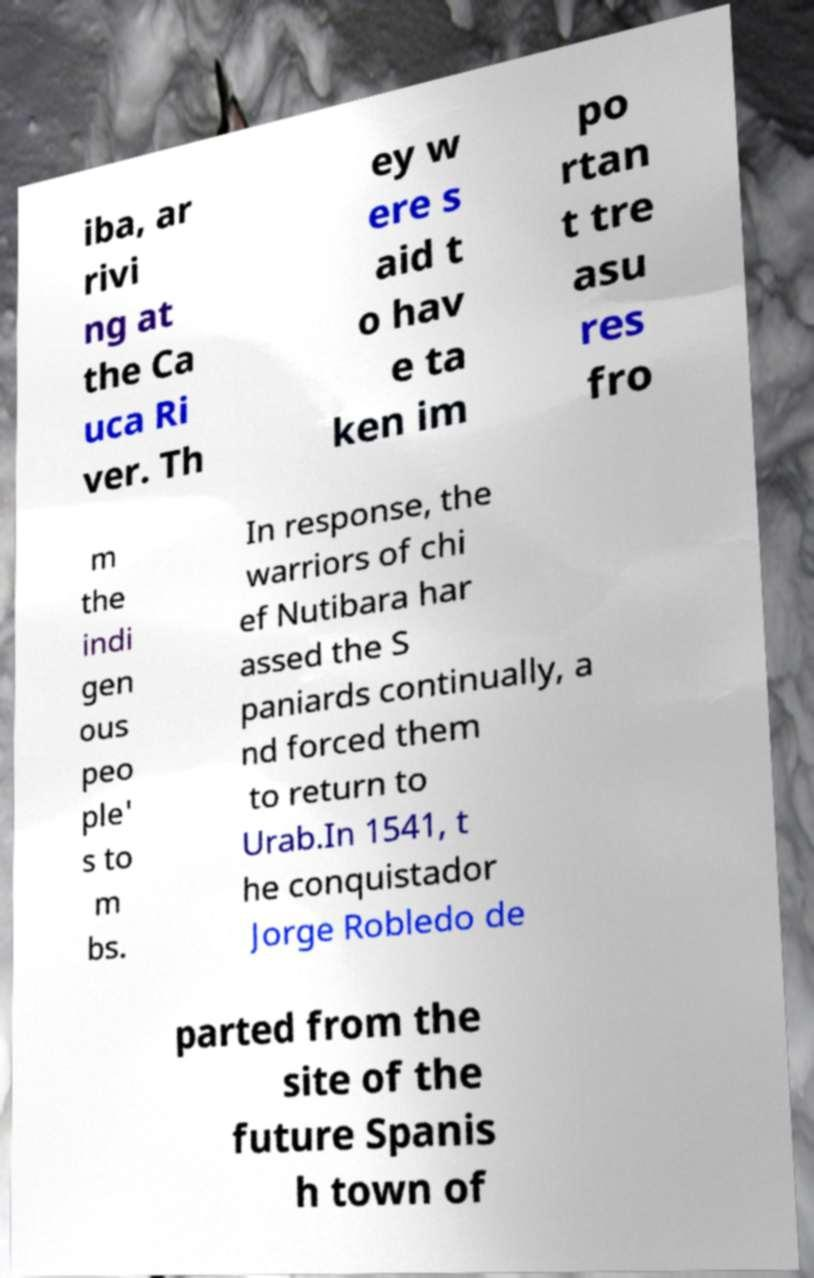Please identify and transcribe the text found in this image. iba, ar rivi ng at the Ca uca Ri ver. Th ey w ere s aid t o hav e ta ken im po rtan t tre asu res fro m the indi gen ous peo ple' s to m bs. In response, the warriors of chi ef Nutibara har assed the S paniards continually, a nd forced them to return to Urab.In 1541, t he conquistador Jorge Robledo de parted from the site of the future Spanis h town of 